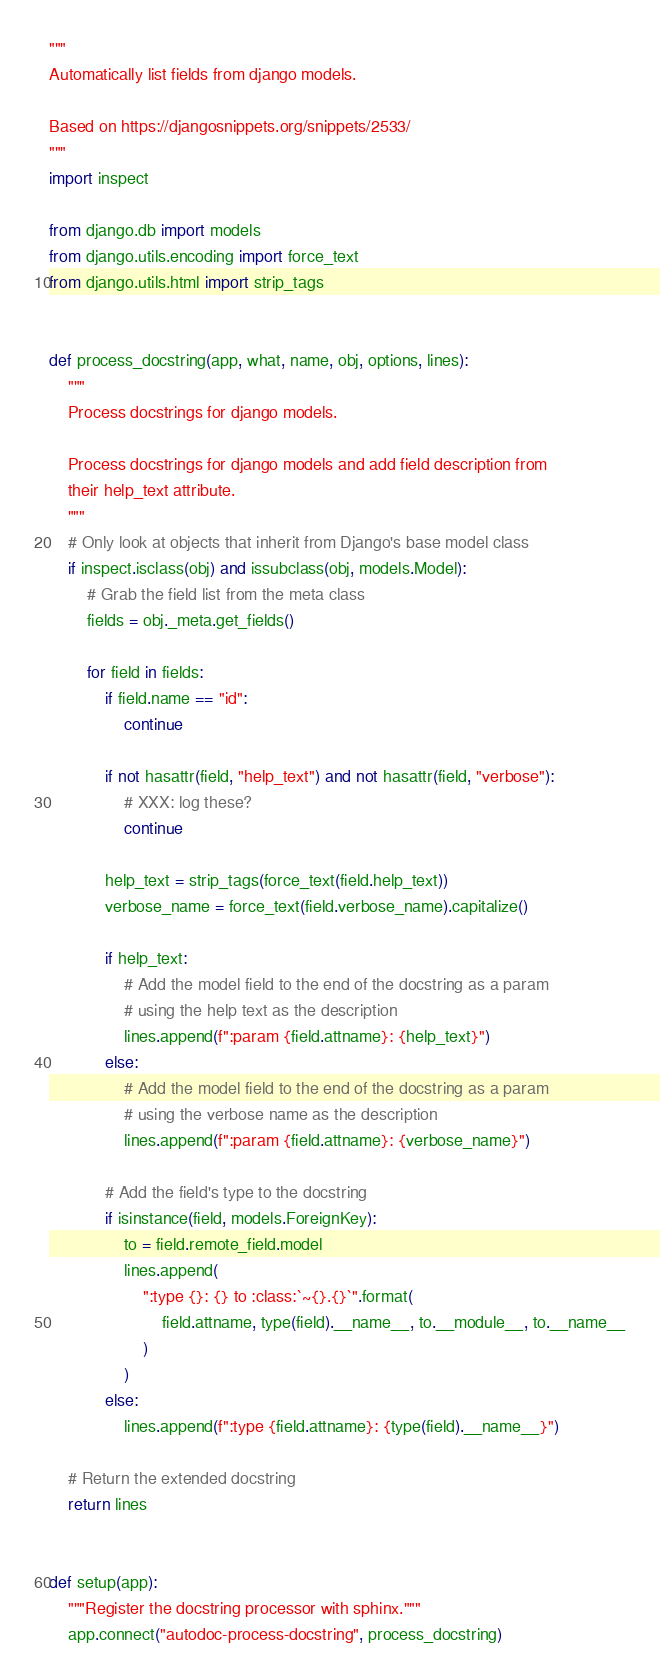<code> <loc_0><loc_0><loc_500><loc_500><_Python_>"""
Automatically list fields from django models.

Based on https://djangosnippets.org/snippets/2533/
"""
import inspect

from django.db import models
from django.utils.encoding import force_text
from django.utils.html import strip_tags


def process_docstring(app, what, name, obj, options, lines):
    """
    Process docstrings for django models.

    Process docstrings for django models and add field description from
    their help_text attribute.
    """
    # Only look at objects that inherit from Django's base model class
    if inspect.isclass(obj) and issubclass(obj, models.Model):
        # Grab the field list from the meta class
        fields = obj._meta.get_fields()

        for field in fields:
            if field.name == "id":
                continue

            if not hasattr(field, "help_text") and not hasattr(field, "verbose"):
                # XXX: log these?
                continue

            help_text = strip_tags(force_text(field.help_text))
            verbose_name = force_text(field.verbose_name).capitalize()

            if help_text:
                # Add the model field to the end of the docstring as a param
                # using the help text as the description
                lines.append(f":param {field.attname}: {help_text}")
            else:
                # Add the model field to the end of the docstring as a param
                # using the verbose name as the description
                lines.append(f":param {field.attname}: {verbose_name}")

            # Add the field's type to the docstring
            if isinstance(field, models.ForeignKey):
                to = field.remote_field.model
                lines.append(
                    ":type {}: {} to :class:`~{}.{}`".format(
                        field.attname, type(field).__name__, to.__module__, to.__name__
                    )
                )
            else:
                lines.append(f":type {field.attname}: {type(field).__name__}")

    # Return the extended docstring
    return lines


def setup(app):
    """Register the docstring processor with sphinx."""
    app.connect("autodoc-process-docstring", process_docstring)
</code> 